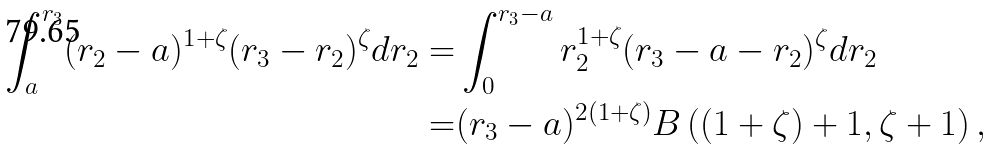<formula> <loc_0><loc_0><loc_500><loc_500>\int _ { a } ^ { r _ { 3 } } ( r _ { 2 } - a ) ^ { 1 + \zeta } ( r _ { 3 } - r _ { 2 } ) ^ { \zeta } d r _ { 2 } = & \int _ { 0 } ^ { r _ { 3 } - a } r _ { 2 } ^ { 1 + \zeta } ( r _ { 3 } - a - r _ { 2 } ) ^ { \zeta } d r _ { 2 } \\ = & ( r _ { 3 } - a ) ^ { 2 ( 1 + \zeta ) } B \left ( ( 1 + \zeta ) + 1 , \zeta + 1 \right ) ,</formula> 